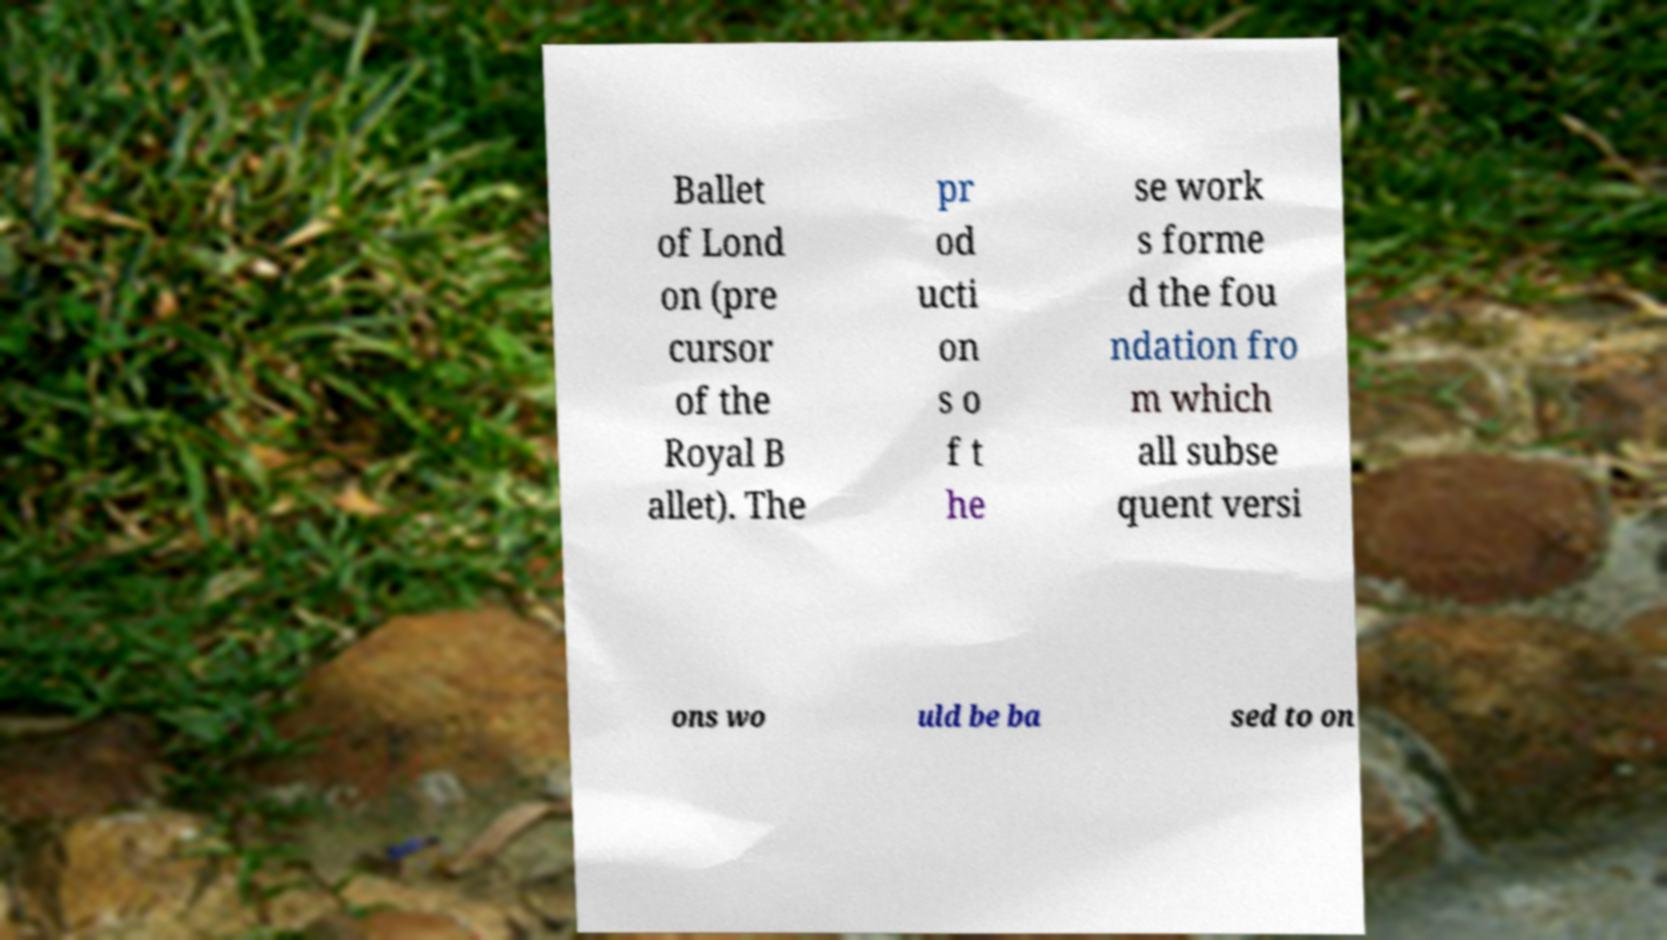For documentation purposes, I need the text within this image transcribed. Could you provide that? Ballet of Lond on (pre cursor of the Royal B allet). The pr od ucti on s o f t he se work s forme d the fou ndation fro m which all subse quent versi ons wo uld be ba sed to on 